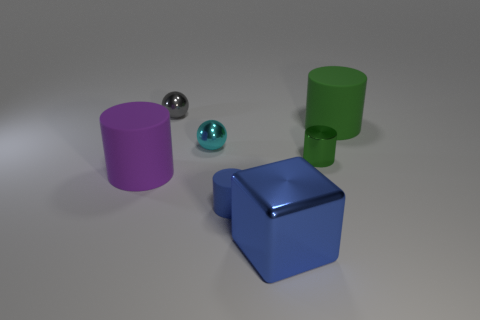Subtract all tiny blue rubber cylinders. How many cylinders are left? 3 Add 2 cylinders. How many objects exist? 9 Subtract 1 cylinders. How many cylinders are left? 3 Subtract all blue cylinders. How many cylinders are left? 3 Subtract all balls. How many objects are left? 5 Subtract all gray blocks. Subtract all brown spheres. How many blocks are left? 1 Subtract all cyan cylinders. How many gray spheres are left? 1 Subtract all yellow shiny objects. Subtract all large purple cylinders. How many objects are left? 6 Add 5 large metal cubes. How many large metal cubes are left? 6 Add 6 small gray things. How many small gray things exist? 7 